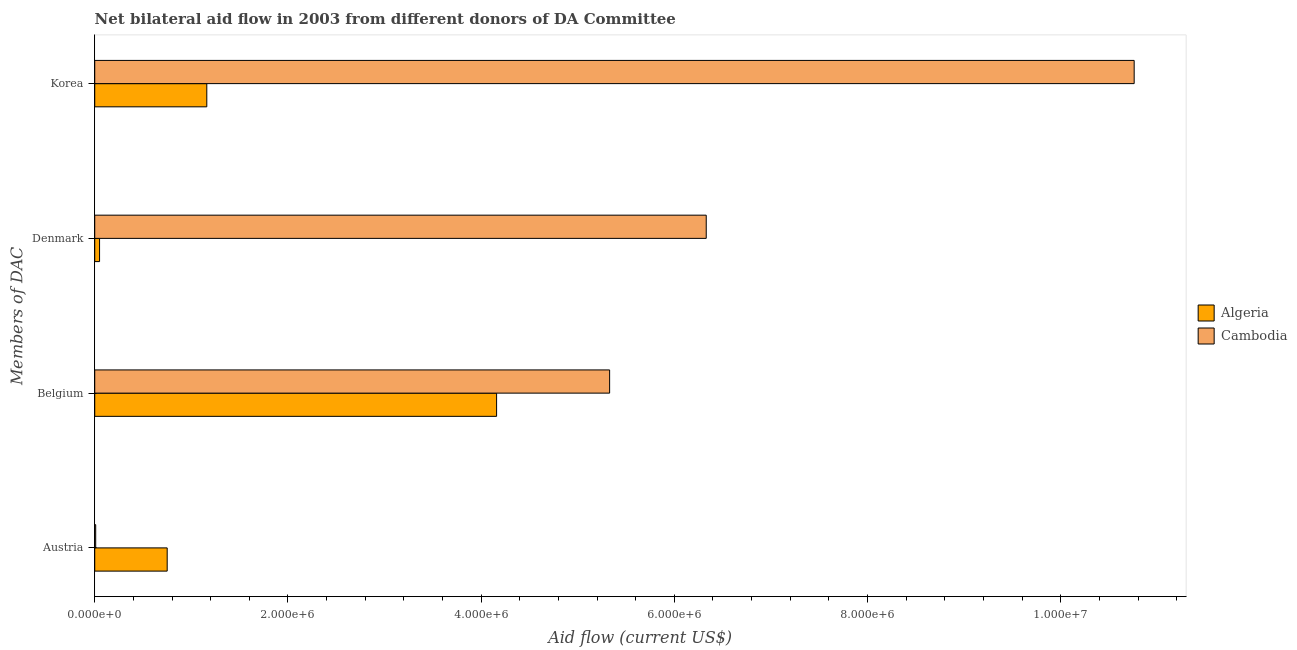How many different coloured bars are there?
Give a very brief answer. 2. Are the number of bars on each tick of the Y-axis equal?
Your answer should be very brief. Yes. How many bars are there on the 2nd tick from the top?
Offer a very short reply. 2. How many bars are there on the 2nd tick from the bottom?
Ensure brevity in your answer.  2. What is the label of the 1st group of bars from the top?
Your response must be concise. Korea. What is the amount of aid given by austria in Algeria?
Offer a very short reply. 7.50e+05. Across all countries, what is the maximum amount of aid given by denmark?
Your response must be concise. 6.33e+06. Across all countries, what is the minimum amount of aid given by austria?
Provide a short and direct response. 10000. In which country was the amount of aid given by denmark maximum?
Ensure brevity in your answer.  Cambodia. In which country was the amount of aid given by belgium minimum?
Your answer should be compact. Algeria. What is the total amount of aid given by denmark in the graph?
Ensure brevity in your answer.  6.38e+06. What is the difference between the amount of aid given by denmark in Algeria and that in Cambodia?
Make the answer very short. -6.28e+06. What is the difference between the amount of aid given by korea in Cambodia and the amount of aid given by denmark in Algeria?
Give a very brief answer. 1.07e+07. What is the average amount of aid given by korea per country?
Your answer should be very brief. 5.96e+06. What is the difference between the amount of aid given by korea and amount of aid given by austria in Algeria?
Keep it short and to the point. 4.10e+05. In how many countries, is the amount of aid given by belgium greater than 5200000 US$?
Offer a very short reply. 1. What is the ratio of the amount of aid given by belgium in Algeria to that in Cambodia?
Offer a terse response. 0.78. What is the difference between the highest and the second highest amount of aid given by denmark?
Offer a terse response. 6.28e+06. What is the difference between the highest and the lowest amount of aid given by belgium?
Your response must be concise. 1.17e+06. What does the 2nd bar from the top in Belgium represents?
Your answer should be compact. Algeria. What does the 1st bar from the bottom in Austria represents?
Your answer should be very brief. Algeria. Are all the bars in the graph horizontal?
Provide a succinct answer. Yes. Are the values on the major ticks of X-axis written in scientific E-notation?
Ensure brevity in your answer.  Yes. Does the graph contain any zero values?
Make the answer very short. No. How many legend labels are there?
Give a very brief answer. 2. How are the legend labels stacked?
Your response must be concise. Vertical. What is the title of the graph?
Provide a short and direct response. Net bilateral aid flow in 2003 from different donors of DA Committee. What is the label or title of the Y-axis?
Keep it short and to the point. Members of DAC. What is the Aid flow (current US$) in Algeria in Austria?
Ensure brevity in your answer.  7.50e+05. What is the Aid flow (current US$) in Algeria in Belgium?
Your response must be concise. 4.16e+06. What is the Aid flow (current US$) in Cambodia in Belgium?
Offer a terse response. 5.33e+06. What is the Aid flow (current US$) in Algeria in Denmark?
Give a very brief answer. 5.00e+04. What is the Aid flow (current US$) in Cambodia in Denmark?
Provide a succinct answer. 6.33e+06. What is the Aid flow (current US$) of Algeria in Korea?
Offer a terse response. 1.16e+06. What is the Aid flow (current US$) of Cambodia in Korea?
Your response must be concise. 1.08e+07. Across all Members of DAC, what is the maximum Aid flow (current US$) of Algeria?
Make the answer very short. 4.16e+06. Across all Members of DAC, what is the maximum Aid flow (current US$) in Cambodia?
Provide a short and direct response. 1.08e+07. What is the total Aid flow (current US$) in Algeria in the graph?
Your answer should be compact. 6.12e+06. What is the total Aid flow (current US$) in Cambodia in the graph?
Your response must be concise. 2.24e+07. What is the difference between the Aid flow (current US$) in Algeria in Austria and that in Belgium?
Keep it short and to the point. -3.41e+06. What is the difference between the Aid flow (current US$) of Cambodia in Austria and that in Belgium?
Ensure brevity in your answer.  -5.32e+06. What is the difference between the Aid flow (current US$) of Algeria in Austria and that in Denmark?
Your response must be concise. 7.00e+05. What is the difference between the Aid flow (current US$) in Cambodia in Austria and that in Denmark?
Your answer should be compact. -6.32e+06. What is the difference between the Aid flow (current US$) of Algeria in Austria and that in Korea?
Your response must be concise. -4.10e+05. What is the difference between the Aid flow (current US$) of Cambodia in Austria and that in Korea?
Your answer should be compact. -1.08e+07. What is the difference between the Aid flow (current US$) in Algeria in Belgium and that in Denmark?
Make the answer very short. 4.11e+06. What is the difference between the Aid flow (current US$) of Cambodia in Belgium and that in Denmark?
Provide a short and direct response. -1.00e+06. What is the difference between the Aid flow (current US$) in Algeria in Belgium and that in Korea?
Your response must be concise. 3.00e+06. What is the difference between the Aid flow (current US$) of Cambodia in Belgium and that in Korea?
Keep it short and to the point. -5.43e+06. What is the difference between the Aid flow (current US$) of Algeria in Denmark and that in Korea?
Ensure brevity in your answer.  -1.11e+06. What is the difference between the Aid flow (current US$) of Cambodia in Denmark and that in Korea?
Ensure brevity in your answer.  -4.43e+06. What is the difference between the Aid flow (current US$) in Algeria in Austria and the Aid flow (current US$) in Cambodia in Belgium?
Ensure brevity in your answer.  -4.58e+06. What is the difference between the Aid flow (current US$) of Algeria in Austria and the Aid flow (current US$) of Cambodia in Denmark?
Keep it short and to the point. -5.58e+06. What is the difference between the Aid flow (current US$) of Algeria in Austria and the Aid flow (current US$) of Cambodia in Korea?
Offer a very short reply. -1.00e+07. What is the difference between the Aid flow (current US$) of Algeria in Belgium and the Aid flow (current US$) of Cambodia in Denmark?
Offer a very short reply. -2.17e+06. What is the difference between the Aid flow (current US$) of Algeria in Belgium and the Aid flow (current US$) of Cambodia in Korea?
Your answer should be compact. -6.60e+06. What is the difference between the Aid flow (current US$) in Algeria in Denmark and the Aid flow (current US$) in Cambodia in Korea?
Offer a very short reply. -1.07e+07. What is the average Aid flow (current US$) in Algeria per Members of DAC?
Your response must be concise. 1.53e+06. What is the average Aid flow (current US$) in Cambodia per Members of DAC?
Offer a very short reply. 5.61e+06. What is the difference between the Aid flow (current US$) in Algeria and Aid flow (current US$) in Cambodia in Austria?
Keep it short and to the point. 7.40e+05. What is the difference between the Aid flow (current US$) of Algeria and Aid flow (current US$) of Cambodia in Belgium?
Your answer should be compact. -1.17e+06. What is the difference between the Aid flow (current US$) of Algeria and Aid flow (current US$) of Cambodia in Denmark?
Your answer should be very brief. -6.28e+06. What is the difference between the Aid flow (current US$) of Algeria and Aid flow (current US$) of Cambodia in Korea?
Offer a terse response. -9.60e+06. What is the ratio of the Aid flow (current US$) in Algeria in Austria to that in Belgium?
Keep it short and to the point. 0.18. What is the ratio of the Aid flow (current US$) of Cambodia in Austria to that in Belgium?
Provide a succinct answer. 0. What is the ratio of the Aid flow (current US$) of Algeria in Austria to that in Denmark?
Ensure brevity in your answer.  15. What is the ratio of the Aid flow (current US$) of Cambodia in Austria to that in Denmark?
Your answer should be very brief. 0. What is the ratio of the Aid flow (current US$) of Algeria in Austria to that in Korea?
Offer a terse response. 0.65. What is the ratio of the Aid flow (current US$) in Cambodia in Austria to that in Korea?
Keep it short and to the point. 0. What is the ratio of the Aid flow (current US$) of Algeria in Belgium to that in Denmark?
Give a very brief answer. 83.2. What is the ratio of the Aid flow (current US$) of Cambodia in Belgium to that in Denmark?
Make the answer very short. 0.84. What is the ratio of the Aid flow (current US$) of Algeria in Belgium to that in Korea?
Provide a succinct answer. 3.59. What is the ratio of the Aid flow (current US$) in Cambodia in Belgium to that in Korea?
Provide a succinct answer. 0.5. What is the ratio of the Aid flow (current US$) of Algeria in Denmark to that in Korea?
Provide a succinct answer. 0.04. What is the ratio of the Aid flow (current US$) of Cambodia in Denmark to that in Korea?
Your response must be concise. 0.59. What is the difference between the highest and the second highest Aid flow (current US$) of Cambodia?
Your response must be concise. 4.43e+06. What is the difference between the highest and the lowest Aid flow (current US$) in Algeria?
Make the answer very short. 4.11e+06. What is the difference between the highest and the lowest Aid flow (current US$) of Cambodia?
Your answer should be compact. 1.08e+07. 